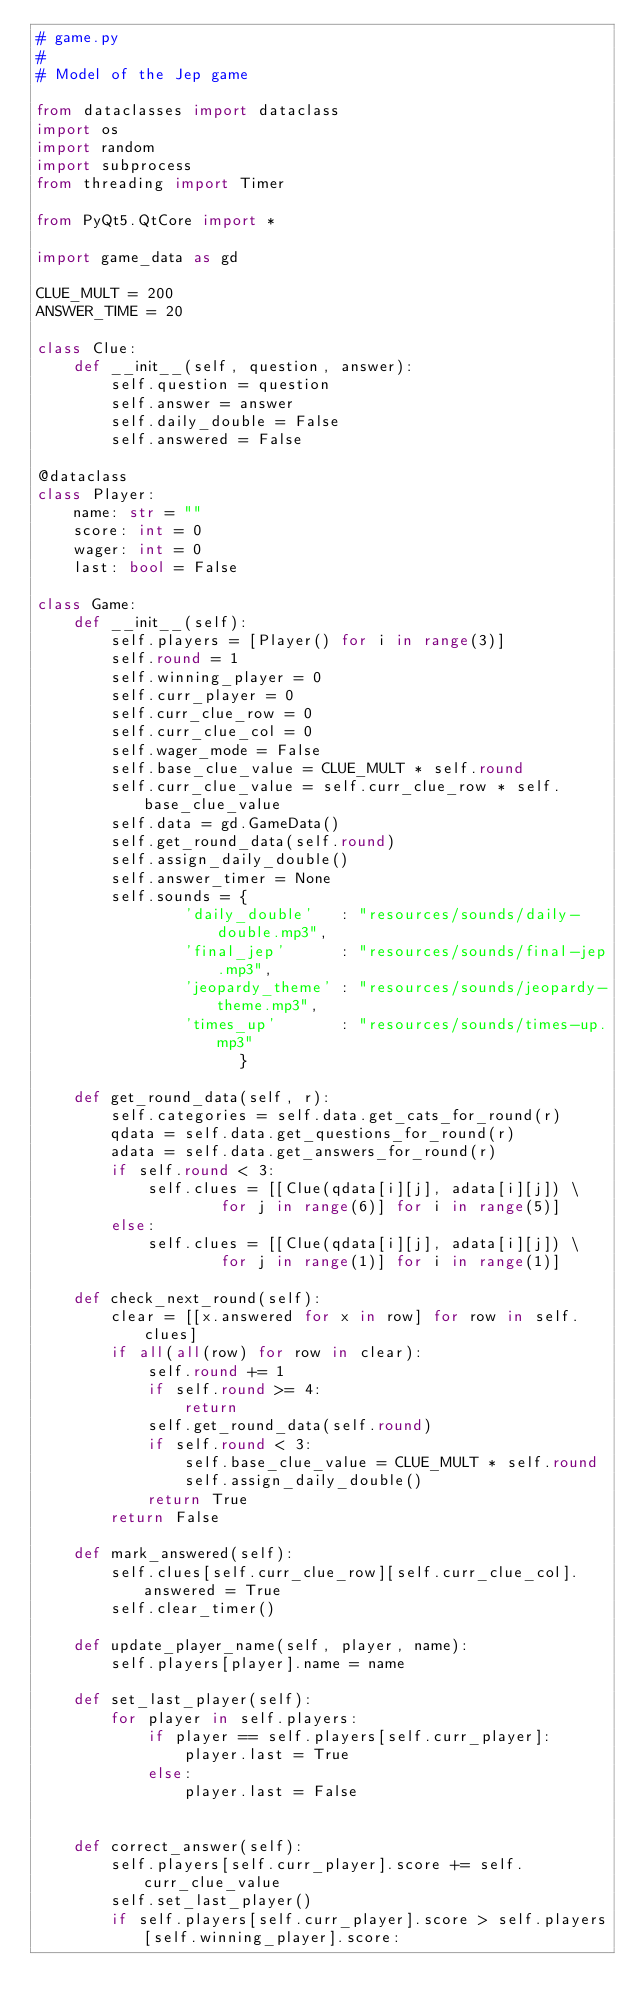<code> <loc_0><loc_0><loc_500><loc_500><_Python_># game.py
#
# Model of the Jep game

from dataclasses import dataclass
import os
import random
import subprocess
from threading import Timer

from PyQt5.QtCore import *

import game_data as gd

CLUE_MULT = 200
ANSWER_TIME = 20

class Clue:
    def __init__(self, question, answer):
        self.question = question
        self.answer = answer
        self.daily_double = False
        self.answered = False

@dataclass
class Player:
    name: str = ""
    score: int = 0
    wager: int = 0
    last: bool = False

class Game:
    def __init__(self):
        self.players = [Player() for i in range(3)]
        self.round = 1
        self.winning_player = 0
        self.curr_player = 0
        self.curr_clue_row = 0
        self.curr_clue_col = 0
        self.wager_mode = False
        self.base_clue_value = CLUE_MULT * self.round
        self.curr_clue_value = self.curr_clue_row * self.base_clue_value
        self.data = gd.GameData()
        self.get_round_data(self.round)
        self.assign_daily_double()
        self.answer_timer = None
        self.sounds = {
                'daily_double'   : "resources/sounds/daily-double.mp3",
                'final_jep'      : "resources/sounds/final-jep.mp3",
                'jeopardy_theme' : "resources/sounds/jeopardy-theme.mp3",
                'times_up'       : "resources/sounds/times-up.mp3"
                      }

    def get_round_data(self, r):
        self.categories = self.data.get_cats_for_round(r)
        qdata = self.data.get_questions_for_round(r)
        adata = self.data.get_answers_for_round(r)
        if self.round < 3:
            self.clues = [[Clue(qdata[i][j], adata[i][j]) \
                    for j in range(6)] for i in range(5)]
        else:
            self.clues = [[Clue(qdata[i][j], adata[i][j]) \
                    for j in range(1)] for i in range(1)]

    def check_next_round(self):
        clear = [[x.answered for x in row] for row in self.clues]
        if all(all(row) for row in clear):
            self.round += 1
            if self.round >= 4:
                return
            self.get_round_data(self.round)
            if self.round < 3:
                self.base_clue_value = CLUE_MULT * self.round
                self.assign_daily_double()
            return True
        return False

    def mark_answered(self):
        self.clues[self.curr_clue_row][self.curr_clue_col].answered = True
        self.clear_timer()

    def update_player_name(self, player, name):
        self.players[player].name = name

    def set_last_player(self):
        for player in self.players:
            if player == self.players[self.curr_player]:
                player.last = True
            else:
                player.last = False


    def correct_answer(self):
        self.players[self.curr_player].score += self.curr_clue_value
        self.set_last_player()
        if self.players[self.curr_player].score > self.players[self.winning_player].score:</code> 